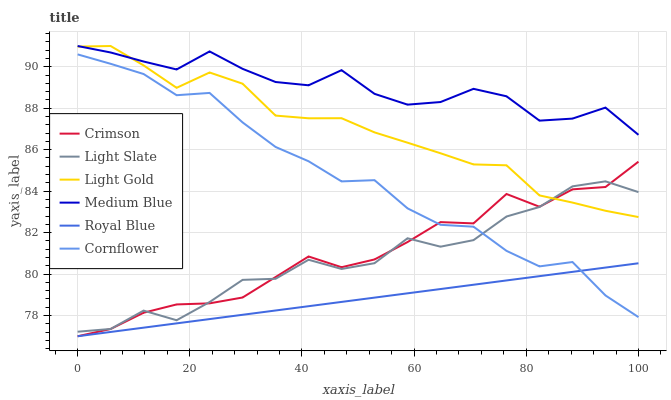Does Light Slate have the minimum area under the curve?
Answer yes or no. No. Does Light Slate have the maximum area under the curve?
Answer yes or no. No. Is Medium Blue the smoothest?
Answer yes or no. No. Is Medium Blue the roughest?
Answer yes or no. No. Does Light Slate have the lowest value?
Answer yes or no. No. Does Light Slate have the highest value?
Answer yes or no. No. Is Cornflower less than Medium Blue?
Answer yes or no. Yes. Is Light Gold greater than Cornflower?
Answer yes or no. Yes. Does Cornflower intersect Medium Blue?
Answer yes or no. No. 